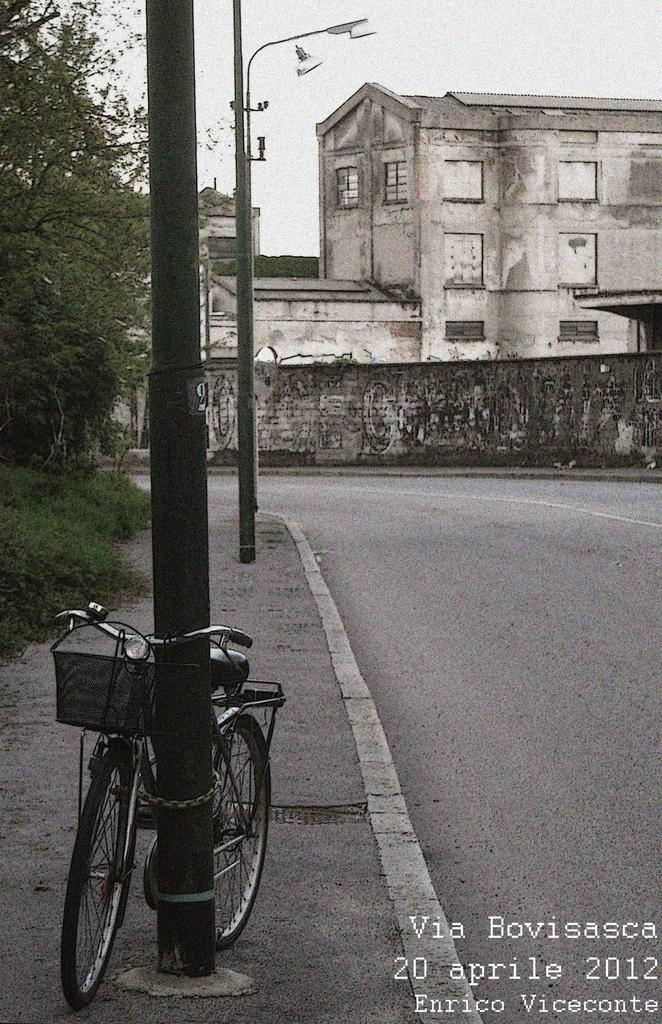What is the main object in the picture? There is a bicycle in the picture. How is the bicycle secured in the picture? The bicycle is tied to a pole. What type of structures can be seen in the picture? There are buildings in the picture. What type of vegetation is present in the picture? There are trees in the picture. What is the condition of the sky in the picture? The sky is clear in the picture. What type of bed is visible in the picture? There is no bed present in the picture; it features a bicycle tied to a pole. What committee is meeting in the picture? There is no committee meeting in the picture; it features a bicycle tied to a pole. 